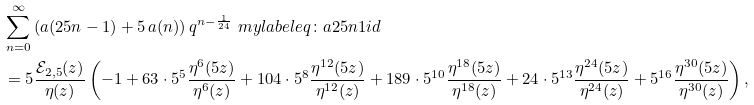Convert formula to latex. <formula><loc_0><loc_0><loc_500><loc_500>& \sum _ { n = 0 } ^ { \infty } \left ( a ( 2 5 n - 1 ) + 5 \, a ( n ) \right ) q ^ { n - \frac { 1 } { 2 4 } } \ m y l a b e l { e q \colon a 2 5 n 1 i d } \\ & = 5 \frac { \mathcal { E } _ { 2 , 5 } ( z ) } { \eta ( z ) } \left ( - 1 + 6 3 \cdot 5 ^ { 5 } \frac { \eta ^ { 6 } ( 5 z ) } { \eta ^ { 6 } ( z ) } + 1 0 4 \cdot 5 ^ { 8 } \frac { \eta ^ { 1 2 } ( 5 z ) } { \eta ^ { 1 2 } ( z ) } + 1 8 9 \cdot 5 ^ { 1 0 } \frac { \eta ^ { 1 8 } ( 5 z ) } { \eta ^ { 1 8 } ( z ) } + 2 4 \cdot 5 ^ { 1 3 } \frac { \eta ^ { 2 4 } ( 5 z ) } { \eta ^ { 2 4 } ( z ) } + 5 ^ { 1 6 } \frac { \eta ^ { 3 0 } ( 5 z ) } { \eta ^ { 3 0 } ( z ) } \right ) ,</formula> 